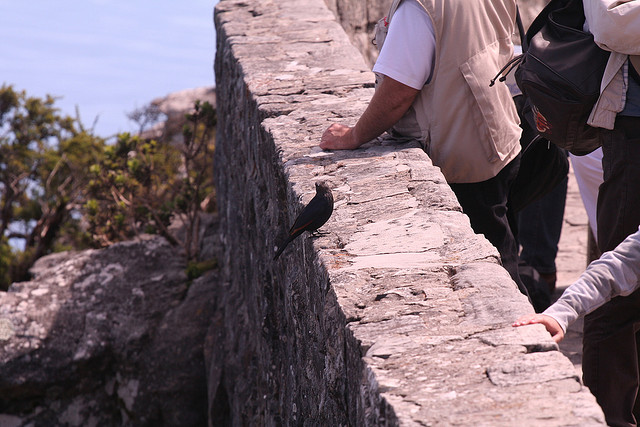<image>How many stones make up the wall? It is unknown how many stones make up the wall. The answer could vary widely. How many stones make up the wall? It is unanswerable how many stones make up the wall. 